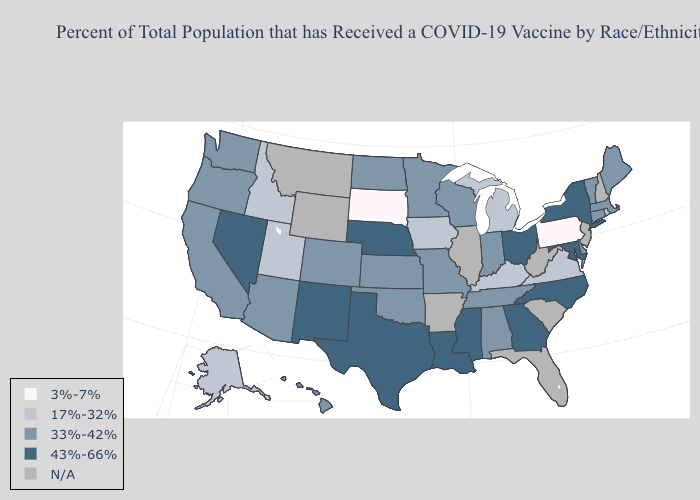What is the value of Nebraska?
Write a very short answer. 43%-66%. Name the states that have a value in the range 43%-66%?
Quick response, please. Georgia, Louisiana, Maryland, Mississippi, Nebraska, Nevada, New Mexico, New York, North Carolina, Ohio, Texas. Name the states that have a value in the range 43%-66%?
Write a very short answer. Georgia, Louisiana, Maryland, Mississippi, Nebraska, Nevada, New Mexico, New York, North Carolina, Ohio, Texas. Does the map have missing data?
Answer briefly. Yes. Which states have the lowest value in the West?
Short answer required. Alaska, Idaho, Utah. How many symbols are there in the legend?
Keep it brief. 5. Name the states that have a value in the range 33%-42%?
Concise answer only. Alabama, Arizona, California, Colorado, Connecticut, Delaware, Hawaii, Indiana, Kansas, Maine, Massachusetts, Minnesota, Missouri, North Dakota, Oklahoma, Oregon, Tennessee, Vermont, Washington, Wisconsin. Among the states that border South Dakota , does Minnesota have the lowest value?
Write a very short answer. No. Does the first symbol in the legend represent the smallest category?
Answer briefly. Yes. What is the value of West Virginia?
Give a very brief answer. N/A. What is the value of Alaska?
Give a very brief answer. 17%-32%. What is the value of Texas?
Short answer required. 43%-66%. Does New York have the lowest value in the USA?
Write a very short answer. No. What is the value of Nevada?
Be succinct. 43%-66%. 